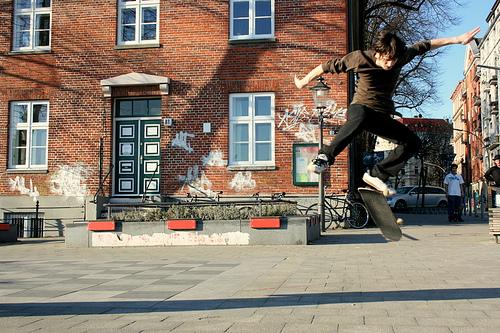What is on the man's foot?
Write a very short answer. Shoe. How many windows are shown on the building to the left?
Quick response, please. 5. What is the building made of?
Be succinct. Brick. 